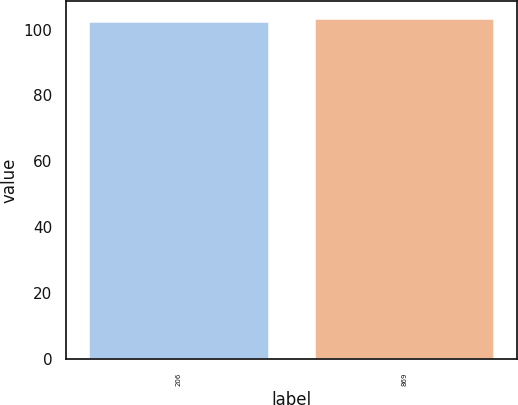Convert chart. <chart><loc_0><loc_0><loc_500><loc_500><bar_chart><fcel>206<fcel>869<nl><fcel>102.63<fcel>103.57<nl></chart> 